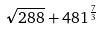<formula> <loc_0><loc_0><loc_500><loc_500>\sqrt { 2 8 8 } + 4 8 1 ^ { \frac { 7 } { 3 } }</formula> 